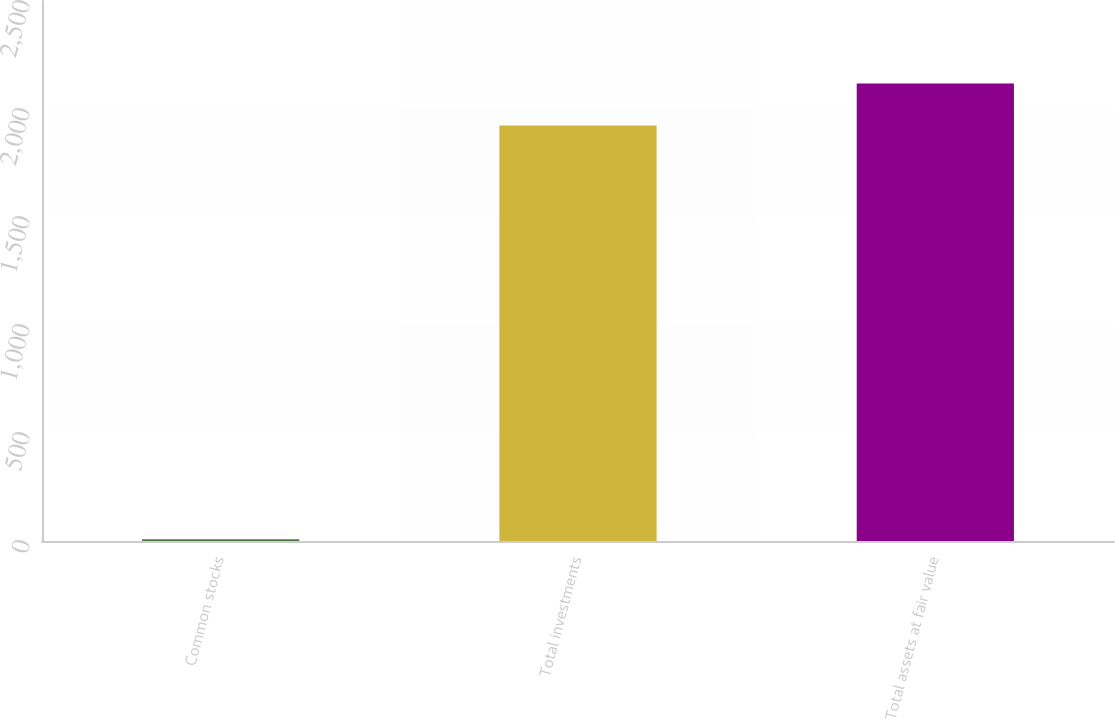<chart> <loc_0><loc_0><loc_500><loc_500><bar_chart><fcel>Common stocks<fcel>Total investments<fcel>Total assets at fair value<nl><fcel>8<fcel>1924<fcel>2118.1<nl></chart> 